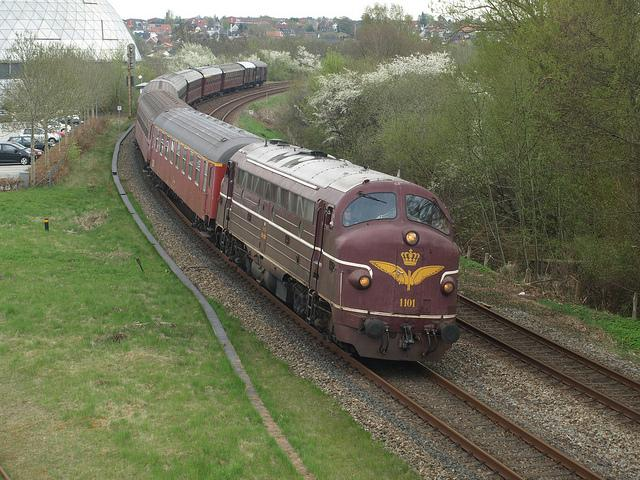What wrestler is named after the long item with the wing logo?

Choices:
A) tugboat
B) tank abbott
C) a-train
D) refrigerator perry a-train 